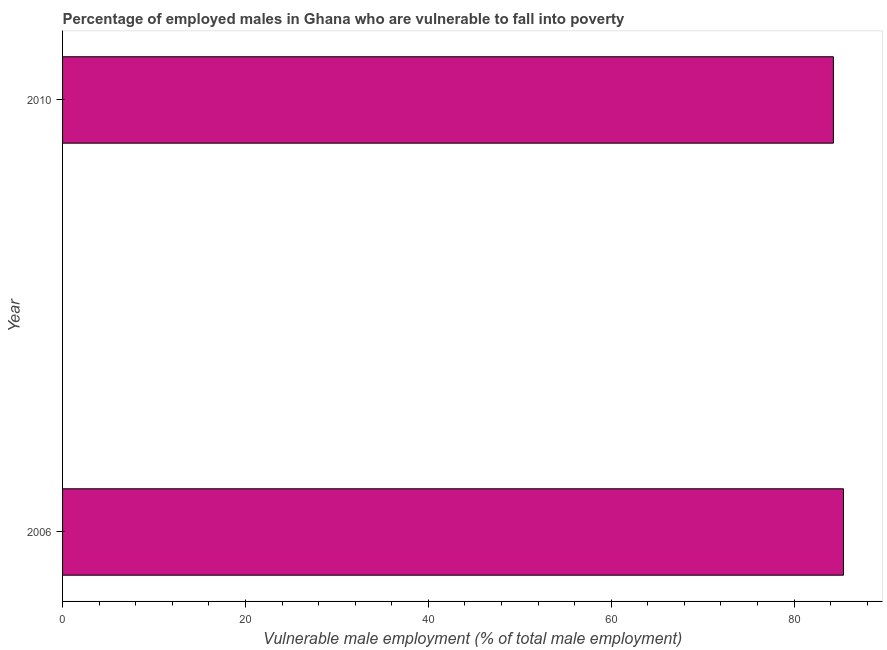What is the title of the graph?
Keep it short and to the point. Percentage of employed males in Ghana who are vulnerable to fall into poverty. What is the label or title of the X-axis?
Give a very brief answer. Vulnerable male employment (% of total male employment). What is the label or title of the Y-axis?
Ensure brevity in your answer.  Year. What is the percentage of employed males who are vulnerable to fall into poverty in 2006?
Your response must be concise. 85.4. Across all years, what is the maximum percentage of employed males who are vulnerable to fall into poverty?
Ensure brevity in your answer.  85.4. Across all years, what is the minimum percentage of employed males who are vulnerable to fall into poverty?
Keep it short and to the point. 84.3. In which year was the percentage of employed males who are vulnerable to fall into poverty maximum?
Offer a very short reply. 2006. What is the sum of the percentage of employed males who are vulnerable to fall into poverty?
Keep it short and to the point. 169.7. What is the difference between the percentage of employed males who are vulnerable to fall into poverty in 2006 and 2010?
Offer a terse response. 1.1. What is the average percentage of employed males who are vulnerable to fall into poverty per year?
Ensure brevity in your answer.  84.85. What is the median percentage of employed males who are vulnerable to fall into poverty?
Ensure brevity in your answer.  84.85. In how many years, is the percentage of employed males who are vulnerable to fall into poverty greater than 56 %?
Keep it short and to the point. 2. Do a majority of the years between 2006 and 2010 (inclusive) have percentage of employed males who are vulnerable to fall into poverty greater than 44 %?
Provide a succinct answer. Yes. Is the percentage of employed males who are vulnerable to fall into poverty in 2006 less than that in 2010?
Provide a succinct answer. No. In how many years, is the percentage of employed males who are vulnerable to fall into poverty greater than the average percentage of employed males who are vulnerable to fall into poverty taken over all years?
Your answer should be very brief. 1. Are all the bars in the graph horizontal?
Make the answer very short. Yes. What is the difference between two consecutive major ticks on the X-axis?
Give a very brief answer. 20. Are the values on the major ticks of X-axis written in scientific E-notation?
Give a very brief answer. No. What is the Vulnerable male employment (% of total male employment) of 2006?
Provide a succinct answer. 85.4. What is the Vulnerable male employment (% of total male employment) of 2010?
Your answer should be very brief. 84.3. What is the difference between the Vulnerable male employment (% of total male employment) in 2006 and 2010?
Ensure brevity in your answer.  1.1. What is the ratio of the Vulnerable male employment (% of total male employment) in 2006 to that in 2010?
Provide a succinct answer. 1.01. 